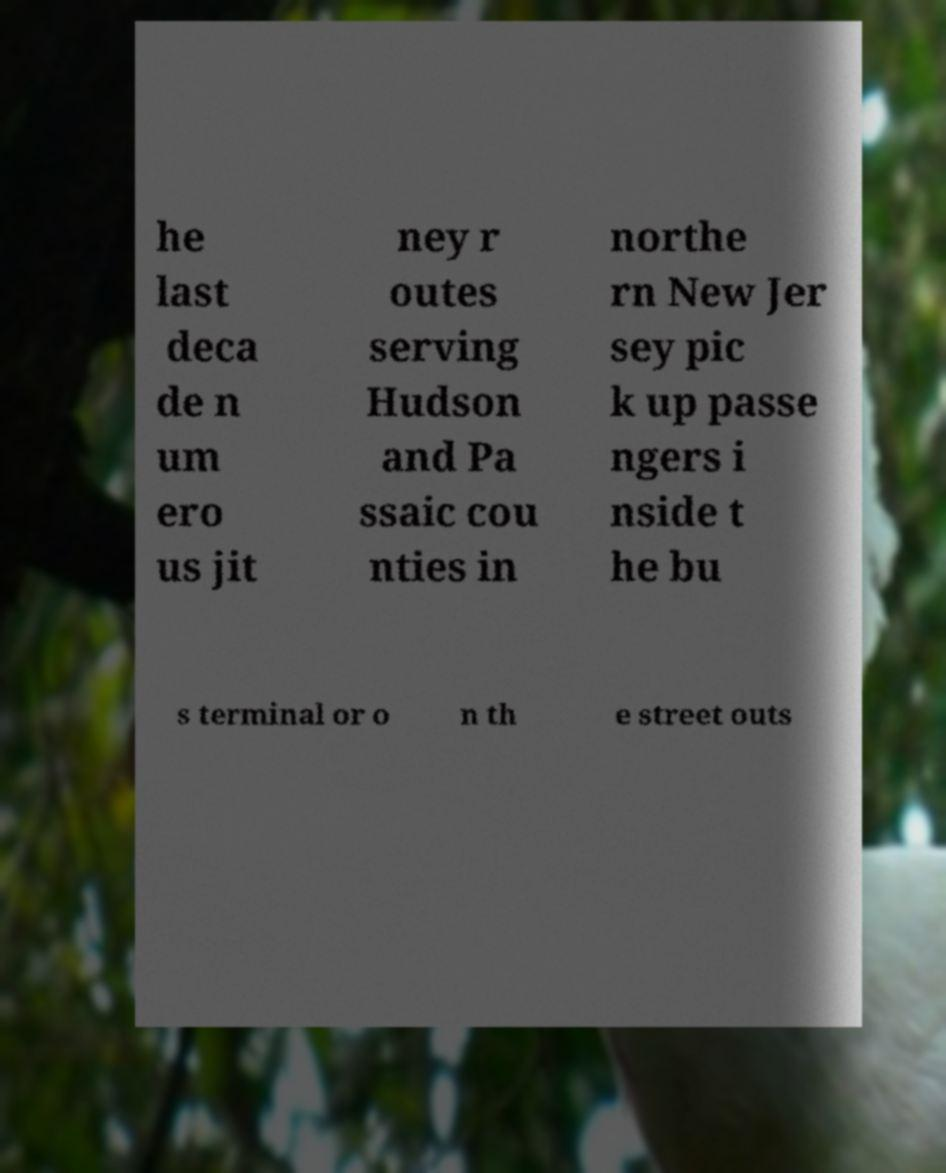Can you read and provide the text displayed in the image?This photo seems to have some interesting text. Can you extract and type it out for me? he last deca de n um ero us jit ney r outes serving Hudson and Pa ssaic cou nties in northe rn New Jer sey pic k up passe ngers i nside t he bu s terminal or o n th e street outs 